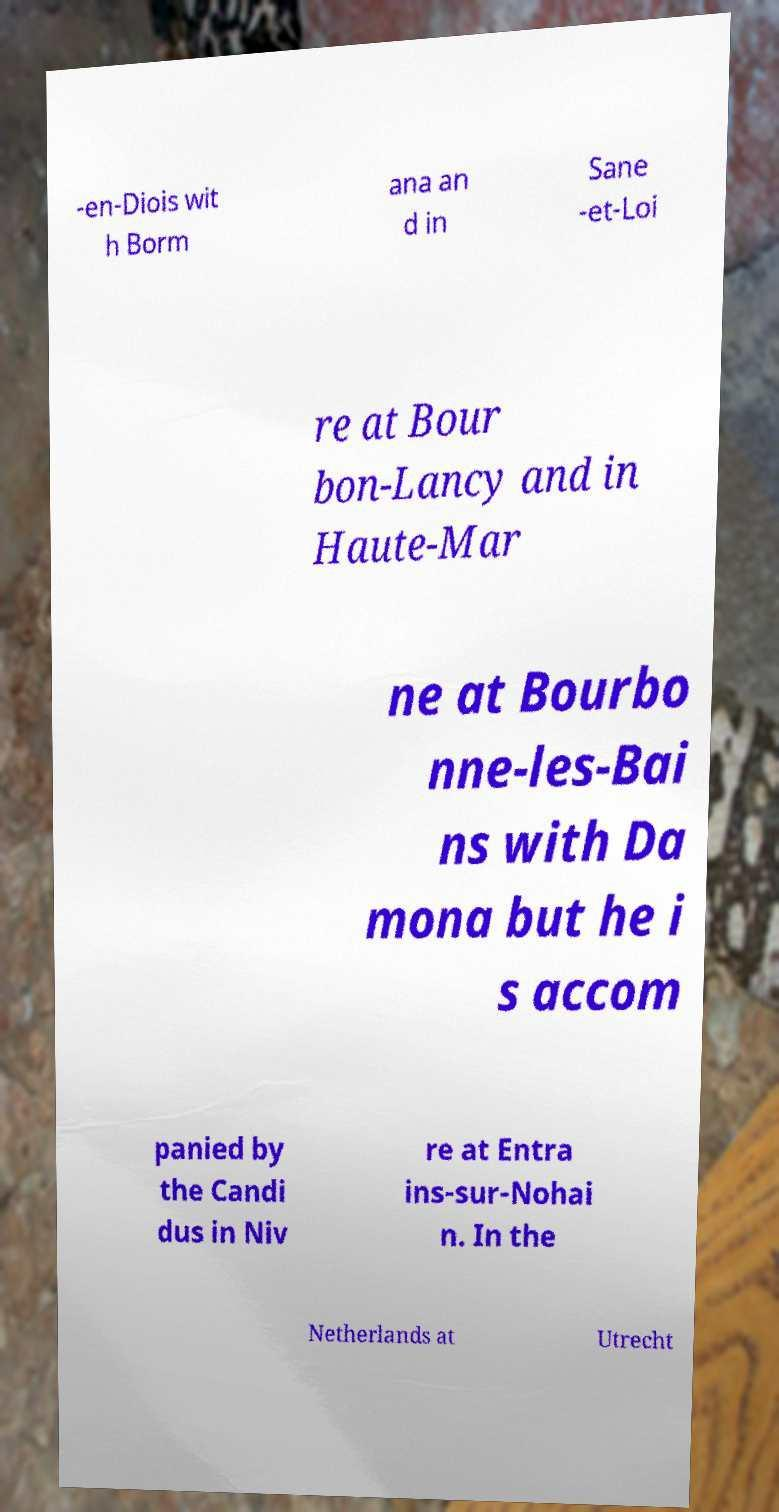There's text embedded in this image that I need extracted. Can you transcribe it verbatim? -en-Diois wit h Borm ana an d in Sane -et-Loi re at Bour bon-Lancy and in Haute-Mar ne at Bourbo nne-les-Bai ns with Da mona but he i s accom panied by the Candi dus in Niv re at Entra ins-sur-Nohai n. In the Netherlands at Utrecht 